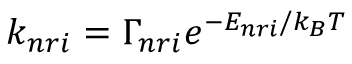<formula> <loc_0><loc_0><loc_500><loc_500>k _ { n r i } = \Gamma _ { n r i } e ^ { - E _ { n r i } / k _ { B } T }</formula> 